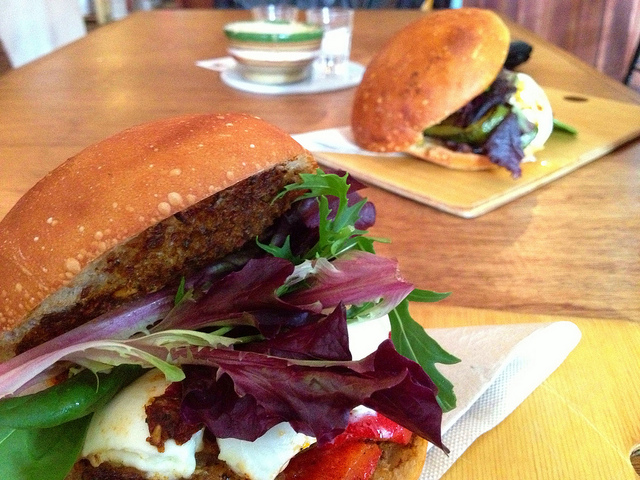Write a detailed description of the given image. The image primarily showcases a large, appetizing sandwich in the foreground on the left side. This sandwich is generously layered with fresh, vibrant greens including lettuce, and nestled between dark, toasted buns. Within the sandwich, other fillings such as slices of grilled vegetables and cheese peek out invitingly. In the background on the upper right, another sandwich is visible, similarly composed but seated on a wooden cutting board. The table surface is scattered with several pieces of lettuce, specifically 17 detached leaves. Additionally, there are two glass containers placed on the table, one on the upper left side and another towards the center right. Three napkins can also be seen: one folded at the middle left, another crumpled at the bottom right, and a third laying across the table in the center. A bowl with a centric green stripe holding some liquid is conspicuously located towards the upper left side near one of the glass containers, and a solitary piece of bread is positioned at the bottom right. 